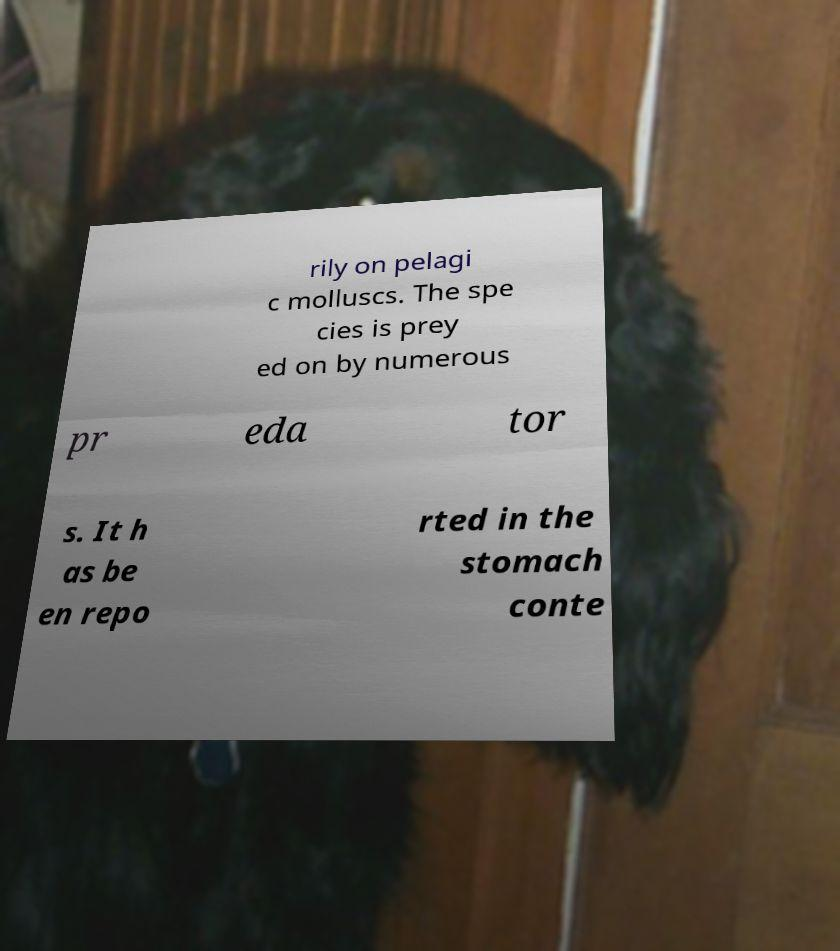Could you extract and type out the text from this image? rily on pelagi c molluscs. The spe cies is prey ed on by numerous pr eda tor s. It h as be en repo rted in the stomach conte 